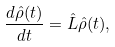<formula> <loc_0><loc_0><loc_500><loc_500>\frac { d \hat { \rho } ( t ) } { d t } = \hat { L } \hat { \rho } ( t ) ,</formula> 